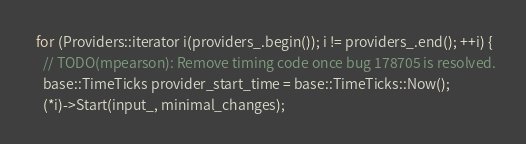<code> <loc_0><loc_0><loc_500><loc_500><_C++_>  for (Providers::iterator i(providers_.begin()); i != providers_.end(); ++i) {
    // TODO(mpearson): Remove timing code once bug 178705 is resolved.
    base::TimeTicks provider_start_time = base::TimeTicks::Now();
    (*i)->Start(input_, minimal_changes);</code> 